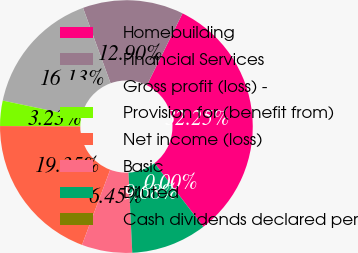Convert chart to OTSL. <chart><loc_0><loc_0><loc_500><loc_500><pie_chart><fcel>Homebuilding<fcel>Financial Services<fcel>Gross profit (loss) -<fcel>Provision for (benefit from)<fcel>Net income (loss)<fcel>Basic<fcel>Diluted<fcel>Cash dividends declared per<nl><fcel>32.25%<fcel>12.9%<fcel>16.13%<fcel>3.23%<fcel>19.35%<fcel>6.45%<fcel>9.68%<fcel>0.0%<nl></chart> 